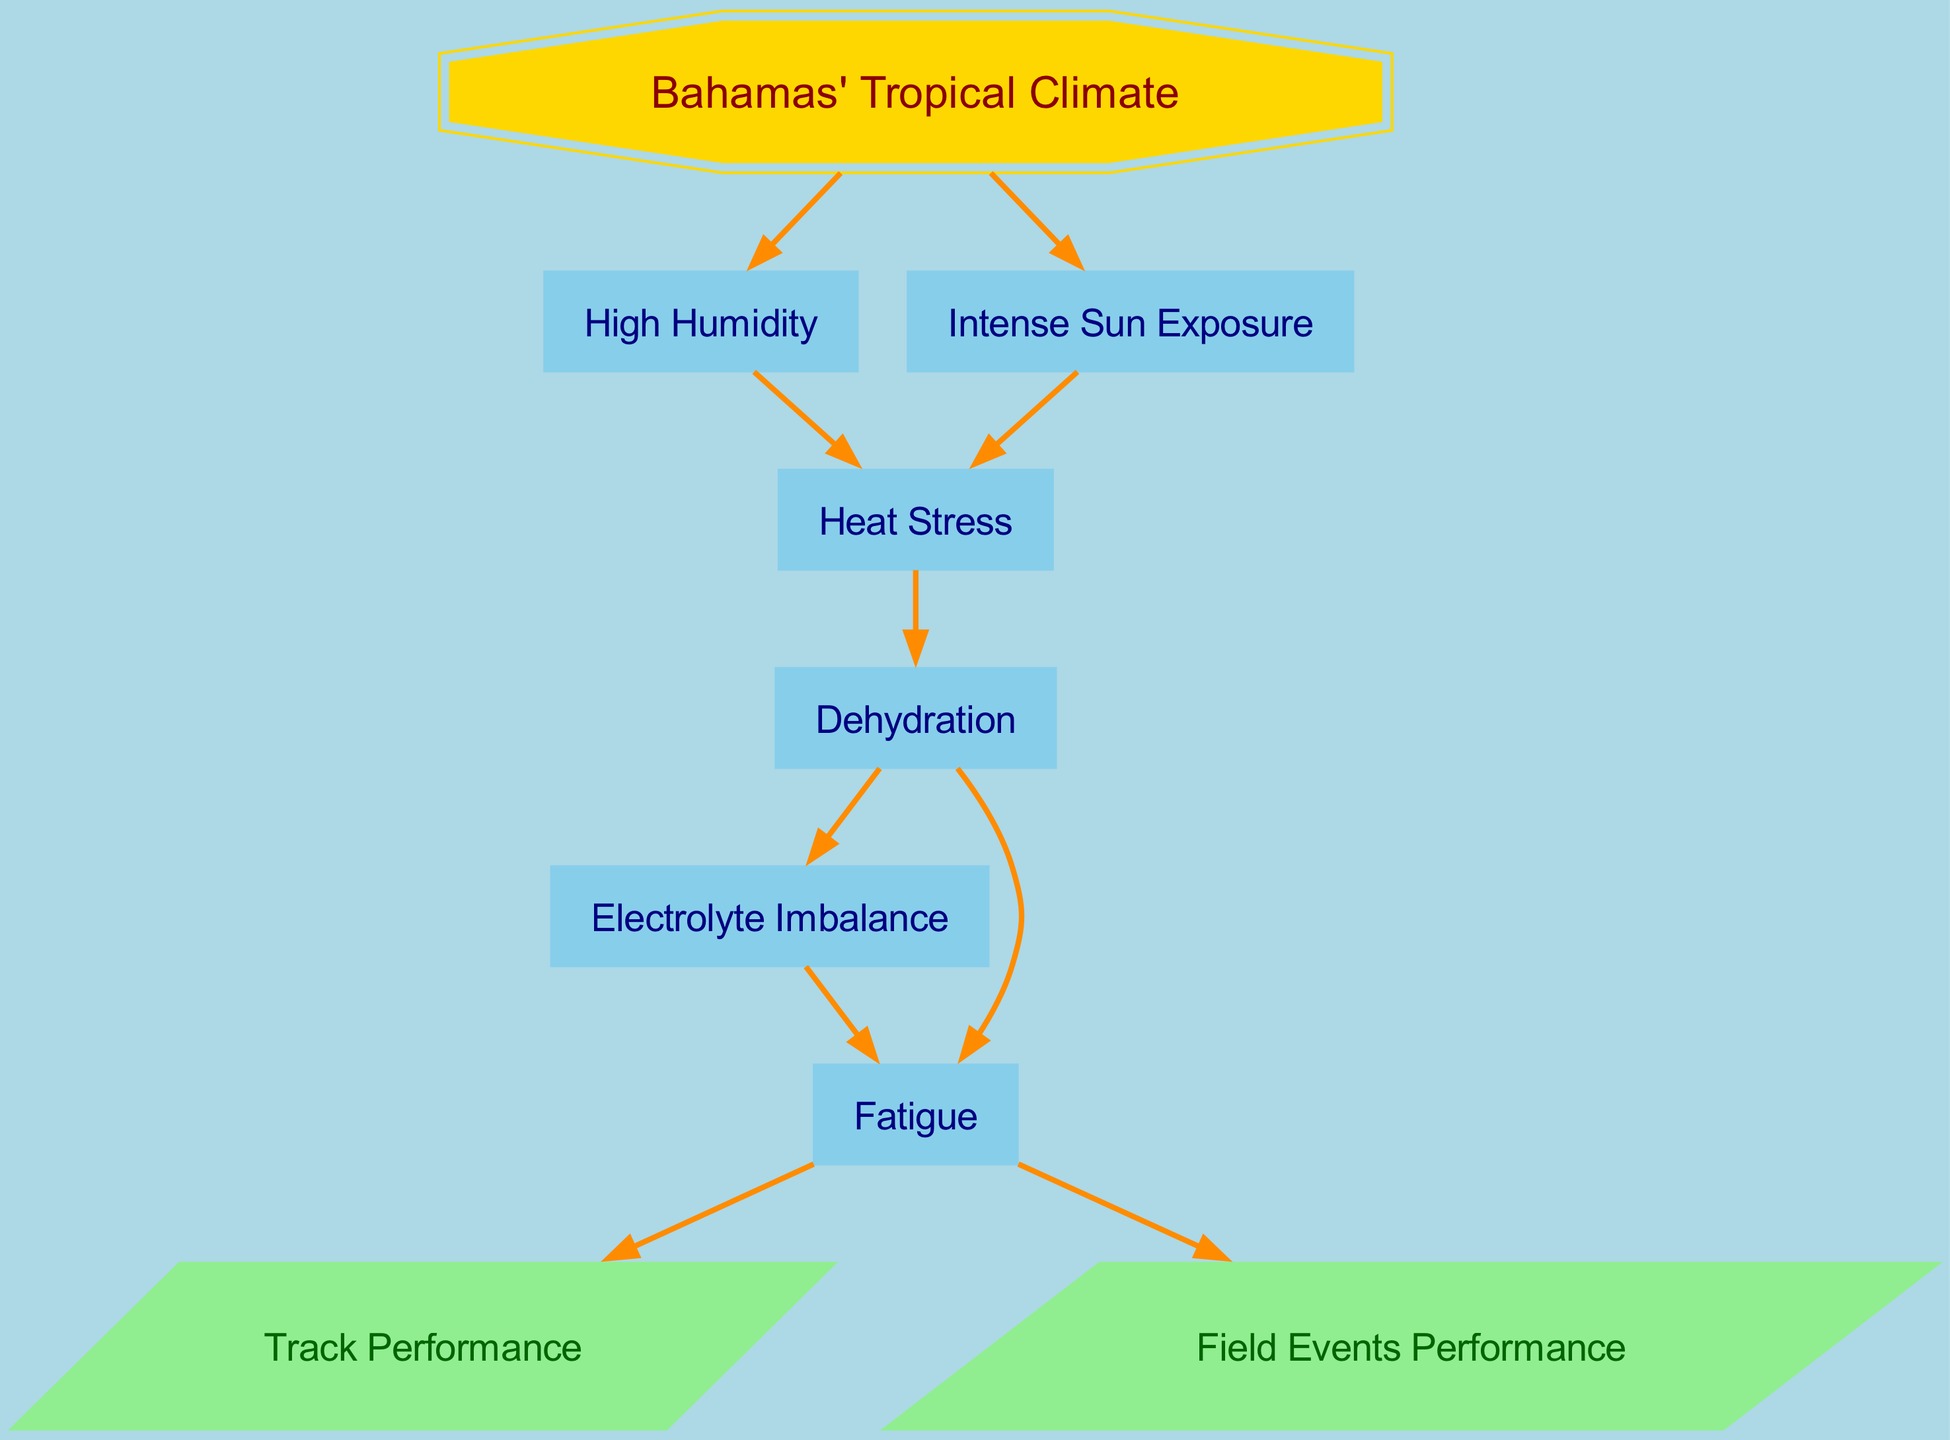What is the starting point of the graph? The diagram begins at the node labeled "Bahamas' Tropical Climate." This is the only node with a doubleoctagon shape, indicating it serves as a primary initiating factor influencing other nodes.
Answer: Bahamas' Tropical Climate How many nodes are present in the diagram? By counting the nodes listed in the provided data, there are a total of eight distinct nodes connected through directed edges.
Answer: 8 What factors lead to Heat Stress? Heat Stress is influenced by two factors: High Humidity and Intense Sun Exposure, as indicated by the directed edges leading into Heat Stress from both of these nodes.
Answer: High Humidity and Intense Sun Exposure Which condition directly results from Dehydration? Dehydration leads directly to both Electrolyte Imbalance and Fatigue, which are respectively connected via directed edges coming from Dehydration.
Answer: Electrolyte Imbalance and Fatigue How does Fatigue affect athletic performance? Fatigue has directed edges leading to both Track Performance and Field Events Performance, indicating it detrimentally affects these specific athletic outputs.
Answer: Track Performance and Field Events Performance What is the flow of factors leading to Fatigue? To reach Fatigue, one must first encounter Heat Stress, which stems from both High Humidity and Intense Sun Exposure. Following this, Heat Stress causes Dehydration, which then causes Fatigue. Thus, the entire flow involves multiple steps as outlined.
Answer: Heat Stress -> Dehydration -> Fatigue How many edges are there in total? The count of edges corresponds to the relationships indicated between nodes, which adds up to a total of nine directed edges in the graph as specified.
Answer: 9 What shape represents performance outcomes in the graph? The performance outcomes, namely Track Performance and Field Events Performance, are represented by parallelogram-shaped nodes, distinguishing them visually from other types of nodes.
Answer: Parallelogram 